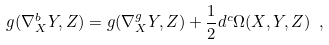Convert formula to latex. <formula><loc_0><loc_0><loc_500><loc_500>g ( \nabla ^ { b } _ { X } Y , Z ) = g ( \nabla ^ { g } _ { X } Y , Z ) + \frac { 1 } { 2 } d ^ { c } \Omega ( X , Y , Z ) \ ,</formula> 